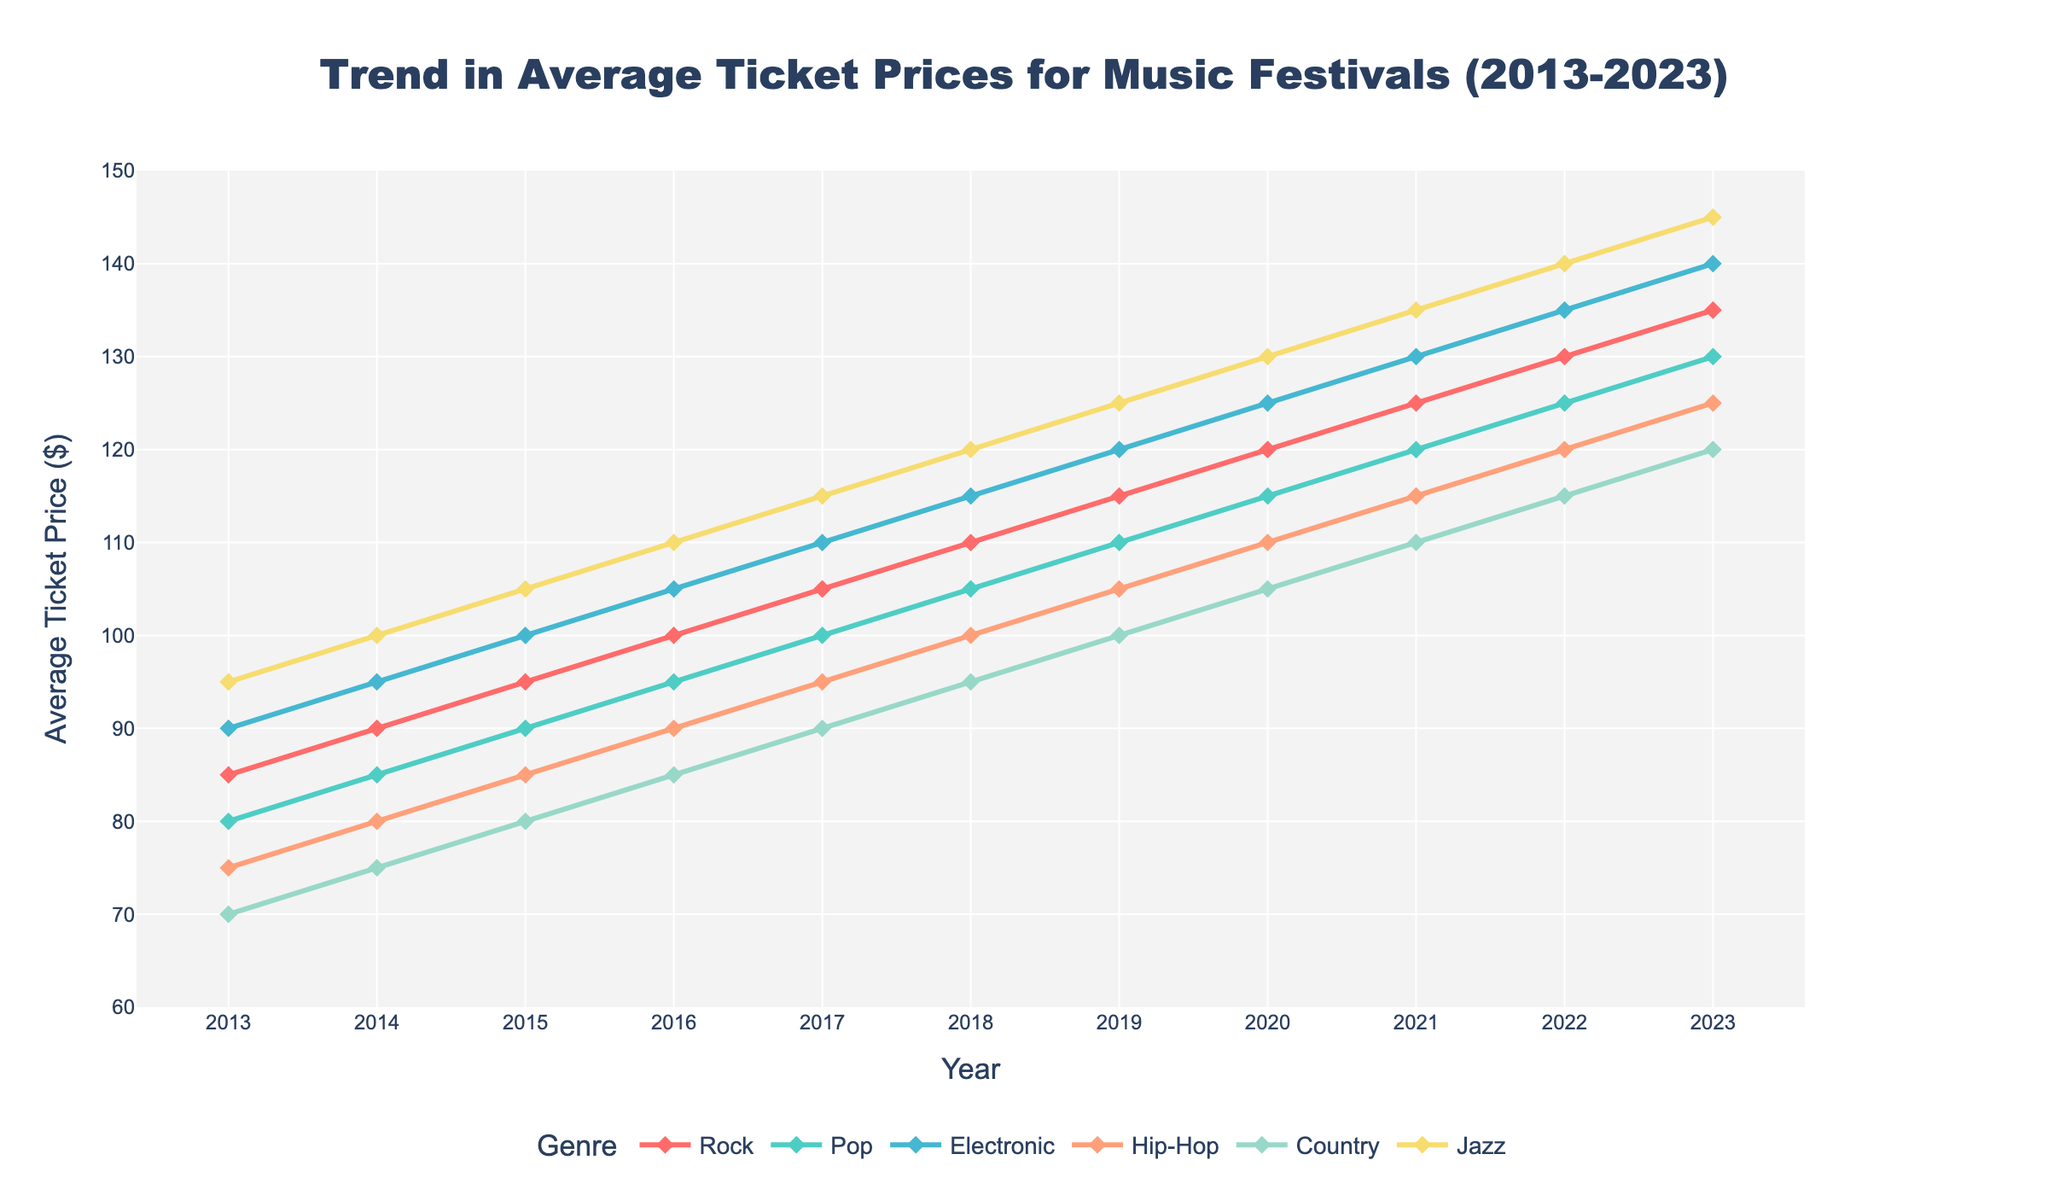What's the trend in average ticket prices for Jazz festivals from 2013 to 2023? From the chart, the average ticket price for Jazz festivals has shown a steady upward trend from 2013 to 2023, starting at $95 in 2013 and reaching $145 in 2023.
Answer: Steady increase Which genre had the highest increase in average ticket prices over the decade? By visually comparing the starting and ending points for each genre, Jazz shows the highest increase. The price for Jazz tickets increased by $50 from $95 in 2013 to $145 in 2023.
Answer: Jazz Between which two consecutive years did Rock festivals see the biggest jump in ticket prices? By examining the line representing Rock festivals, the largest jump is between 2018 and 2019, where the price increased from $110 to $115.
Answer: 2018-2019 In 2023, which genre had the lowest average ticket price? Looking at the data points for 2023, Country festivals had the lowest average ticket price at $120.
Answer: Country How much more expensive are Electronic festival tickets compared to Hip-Hop festival tickets in 2023? In 2023, the average ticket price for Electronic festivals was $140 and for Hip-Hop festivals, it was $125. The difference is $140 - $125 = $15.
Answer: $15 Did any genre have a year where its average ticket price decreased compared to the previous year? By observing the trend lines for all genres, there are no instances where any genre shows a year-over-year decrease in ticket prices.
Answer: No On average, how much did ticket prices increase each year for Country festivals over the decade? Ticket prices for Country festivals started at $70 in 2013 and ended at $120 in 2023. That's an increase of $120 - $70 = $50 over 10 years. Therefore, the average yearly increase is $50 / 10 = $5.
Answer: $5 Which genre had the highest average ticket price in both 2013 and 2023? By referring to the data points for both years, Jazz had the highest average ticket price in both 2013 ($95) and 2023 ($145).
Answer: Jazz Compare the 2015 average ticket prices for Pop and Hip-Hop festivals; which was higher, and by how much? In 2015, the average ticket price for Pop festivals was $90, and for Hip-Hop festivals, it was $85. The difference is $90 - $85 = $5, with Pop being higher.
Answer: Pop by $5 